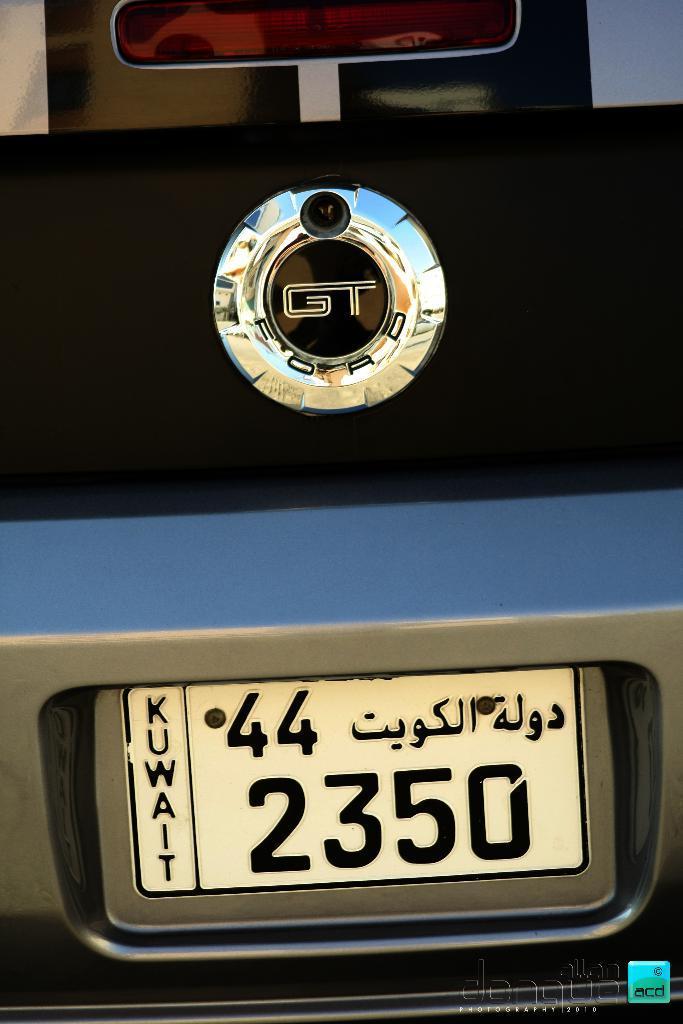How would you summarize this image in a sentence or two? In the center of the image we can see logo and number plate of a car. 